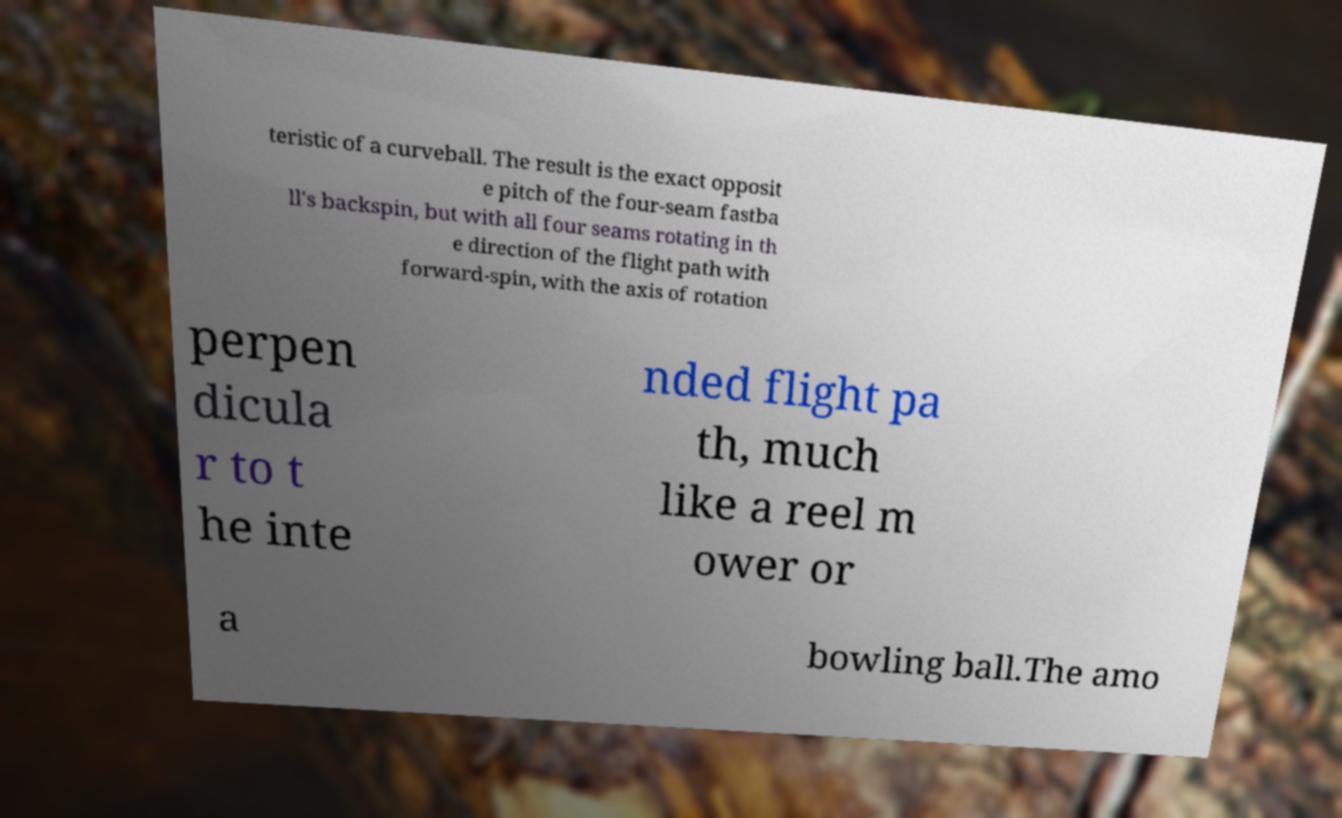For documentation purposes, I need the text within this image transcribed. Could you provide that? teristic of a curveball. The result is the exact opposit e pitch of the four-seam fastba ll's backspin, but with all four seams rotating in th e direction of the flight path with forward-spin, with the axis of rotation perpen dicula r to t he inte nded flight pa th, much like a reel m ower or a bowling ball.The amo 